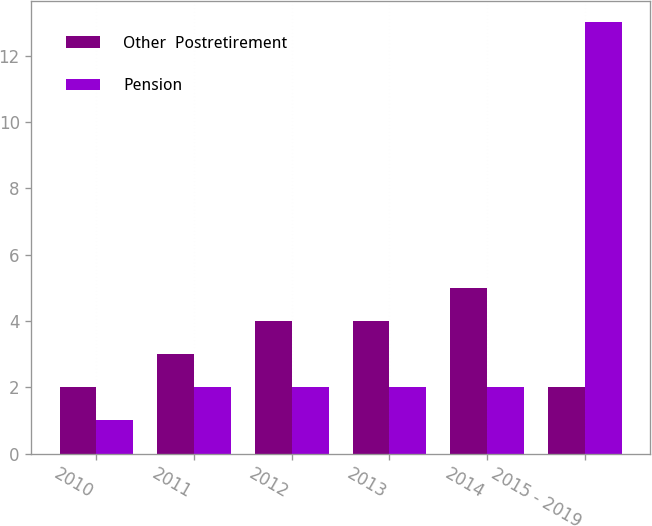Convert chart to OTSL. <chart><loc_0><loc_0><loc_500><loc_500><stacked_bar_chart><ecel><fcel>2010<fcel>2011<fcel>2012<fcel>2013<fcel>2014<fcel>2015 - 2019<nl><fcel>Other  Postretirement<fcel>2<fcel>3<fcel>4<fcel>4<fcel>5<fcel>2<nl><fcel>Pension<fcel>1<fcel>2<fcel>2<fcel>2<fcel>2<fcel>13<nl></chart> 